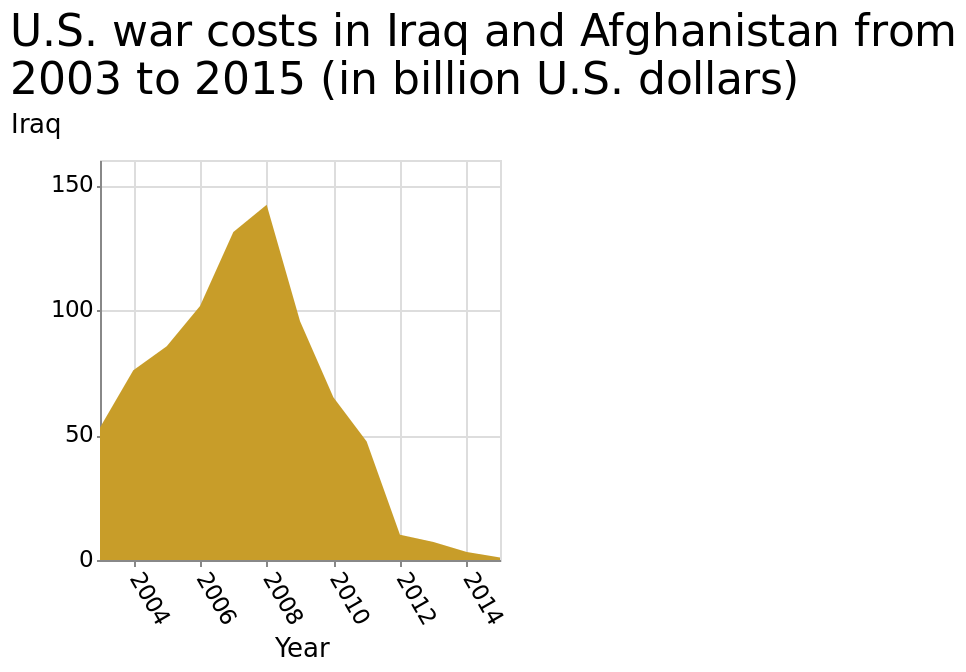<image>
What are the labels on the x-axis and y-axis of the area chart?  The x-axis is labeled as "Year" and the y-axis is labeled as "U.S. war costs in Iraq". What is the range of the x-axis on the area chart?  The x-axis of the area chart ranges from 2004 to 2014. When did war costs in the US peak?  War costs in the US peaked in 2008. please enumerates aspects of the construction of the chart Here a is a area chart labeled U.S. war costs in Iraq and Afghanistan from 2003 to 2015 (in billion U.S. dollars). Iraq is measured along the y-axis. Along the x-axis, Year is measured with a linear scale with a minimum of 2004 and a maximum of 2014. How have war costs in the US been trending since 2008?  War costs in the US have been declining since 2008. 